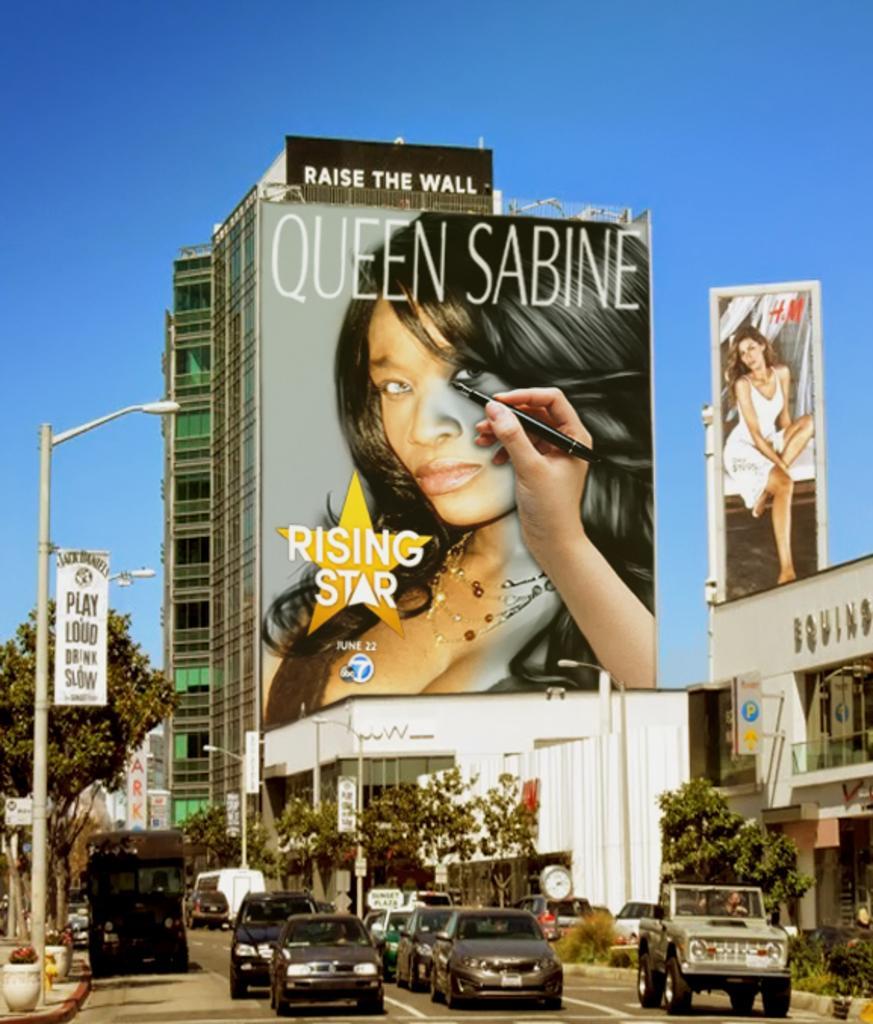Could you give a brief overview of what you see in this image? In this image at the bottom there are cars, vehicles, street lights, posters, trees, buildings, plants and road. In the middle there are buildings, posters, sign boards and sky. 